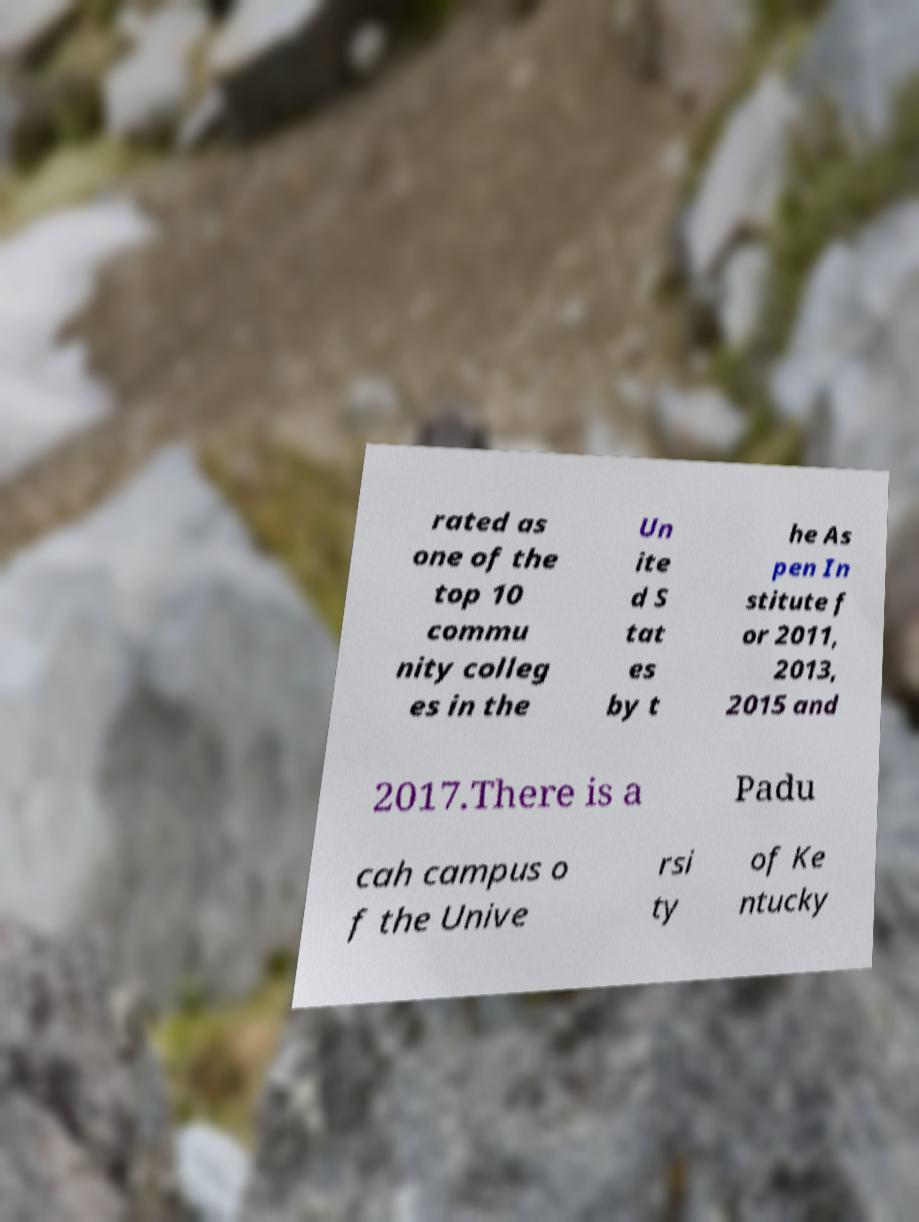Can you read and provide the text displayed in the image?This photo seems to have some interesting text. Can you extract and type it out for me? rated as one of the top 10 commu nity colleg es in the Un ite d S tat es by t he As pen In stitute f or 2011, 2013, 2015 and 2017.There is a Padu cah campus o f the Unive rsi ty of Ke ntucky 